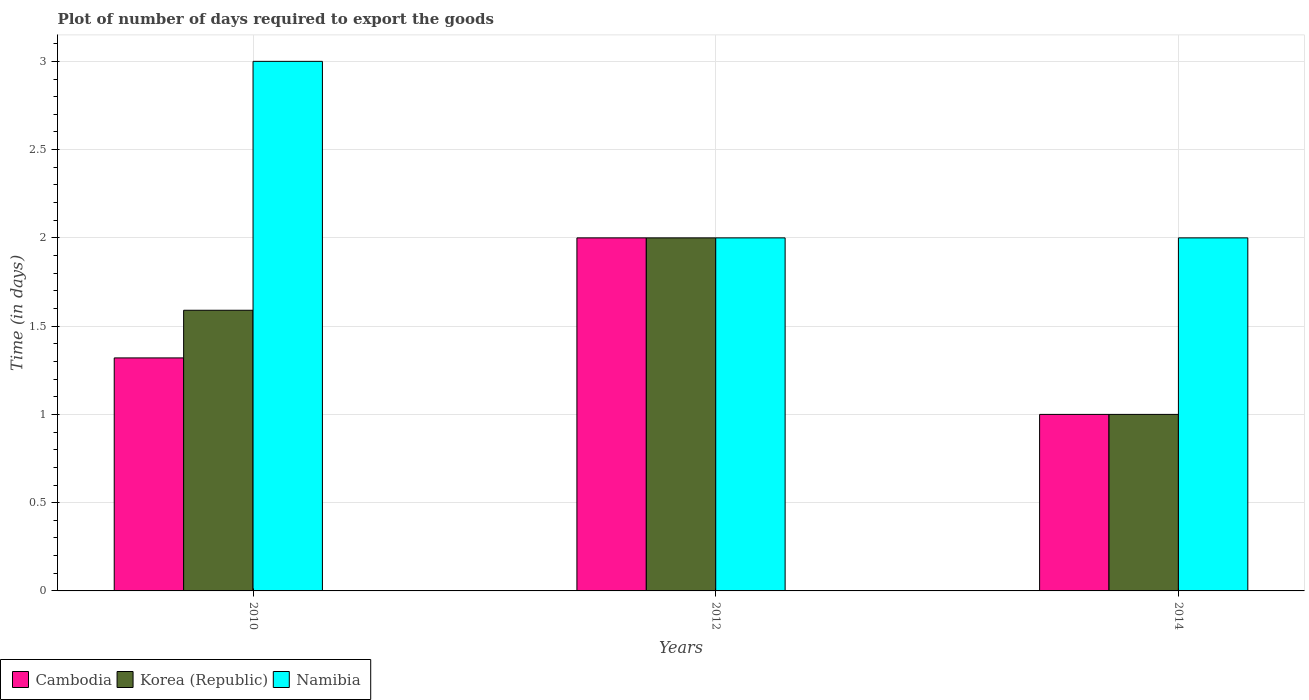Are the number of bars per tick equal to the number of legend labels?
Keep it short and to the point. Yes. How many bars are there on the 2nd tick from the right?
Your response must be concise. 3. What is the time required to export goods in Korea (Republic) in 2010?
Give a very brief answer. 1.59. Across all years, what is the maximum time required to export goods in Cambodia?
Provide a short and direct response. 2. Across all years, what is the minimum time required to export goods in Korea (Republic)?
Provide a succinct answer. 1. What is the total time required to export goods in Cambodia in the graph?
Provide a succinct answer. 4.32. What is the difference between the time required to export goods in Namibia in 2010 and that in 2012?
Offer a very short reply. 1. What is the average time required to export goods in Namibia per year?
Provide a short and direct response. 2.33. What is the ratio of the time required to export goods in Cambodia in 2012 to that in 2014?
Keep it short and to the point. 2. Is the difference between the time required to export goods in Korea (Republic) in 2010 and 2012 greater than the difference between the time required to export goods in Cambodia in 2010 and 2012?
Make the answer very short. Yes. What is the difference between the highest and the second highest time required to export goods in Cambodia?
Keep it short and to the point. 0.68. What is the difference between the highest and the lowest time required to export goods in Namibia?
Provide a succinct answer. 1. Is the sum of the time required to export goods in Namibia in 2010 and 2012 greater than the maximum time required to export goods in Cambodia across all years?
Your response must be concise. Yes. What does the 2nd bar from the left in 2014 represents?
Provide a short and direct response. Korea (Republic). What does the 1st bar from the right in 2014 represents?
Your answer should be very brief. Namibia. Are all the bars in the graph horizontal?
Your answer should be very brief. No. How many years are there in the graph?
Offer a terse response. 3. Does the graph contain any zero values?
Your answer should be very brief. No. Does the graph contain grids?
Make the answer very short. Yes. How are the legend labels stacked?
Provide a short and direct response. Horizontal. What is the title of the graph?
Offer a very short reply. Plot of number of days required to export the goods. Does "Czech Republic" appear as one of the legend labels in the graph?
Provide a succinct answer. No. What is the label or title of the X-axis?
Keep it short and to the point. Years. What is the label or title of the Y-axis?
Provide a short and direct response. Time (in days). What is the Time (in days) of Cambodia in 2010?
Offer a terse response. 1.32. What is the Time (in days) in Korea (Republic) in 2010?
Your answer should be very brief. 1.59. What is the Time (in days) of Namibia in 2012?
Provide a succinct answer. 2. What is the Time (in days) of Cambodia in 2014?
Keep it short and to the point. 1. What is the Time (in days) of Korea (Republic) in 2014?
Your response must be concise. 1. Across all years, what is the minimum Time (in days) in Cambodia?
Provide a succinct answer. 1. What is the total Time (in days) in Cambodia in the graph?
Offer a terse response. 4.32. What is the total Time (in days) of Korea (Republic) in the graph?
Provide a short and direct response. 4.59. What is the total Time (in days) in Namibia in the graph?
Your response must be concise. 7. What is the difference between the Time (in days) in Cambodia in 2010 and that in 2012?
Offer a very short reply. -0.68. What is the difference between the Time (in days) of Korea (Republic) in 2010 and that in 2012?
Offer a terse response. -0.41. What is the difference between the Time (in days) of Namibia in 2010 and that in 2012?
Your answer should be very brief. 1. What is the difference between the Time (in days) in Cambodia in 2010 and that in 2014?
Give a very brief answer. 0.32. What is the difference between the Time (in days) in Korea (Republic) in 2010 and that in 2014?
Provide a succinct answer. 0.59. What is the difference between the Time (in days) in Cambodia in 2010 and the Time (in days) in Korea (Republic) in 2012?
Make the answer very short. -0.68. What is the difference between the Time (in days) in Cambodia in 2010 and the Time (in days) in Namibia in 2012?
Your answer should be compact. -0.68. What is the difference between the Time (in days) of Korea (Republic) in 2010 and the Time (in days) of Namibia in 2012?
Provide a succinct answer. -0.41. What is the difference between the Time (in days) of Cambodia in 2010 and the Time (in days) of Korea (Republic) in 2014?
Provide a short and direct response. 0.32. What is the difference between the Time (in days) of Cambodia in 2010 and the Time (in days) of Namibia in 2014?
Provide a succinct answer. -0.68. What is the difference between the Time (in days) in Korea (Republic) in 2010 and the Time (in days) in Namibia in 2014?
Ensure brevity in your answer.  -0.41. What is the difference between the Time (in days) of Cambodia in 2012 and the Time (in days) of Namibia in 2014?
Your response must be concise. 0. What is the difference between the Time (in days) in Korea (Republic) in 2012 and the Time (in days) in Namibia in 2014?
Offer a terse response. 0. What is the average Time (in days) in Cambodia per year?
Keep it short and to the point. 1.44. What is the average Time (in days) in Korea (Republic) per year?
Offer a terse response. 1.53. What is the average Time (in days) in Namibia per year?
Your answer should be compact. 2.33. In the year 2010, what is the difference between the Time (in days) in Cambodia and Time (in days) in Korea (Republic)?
Your answer should be compact. -0.27. In the year 2010, what is the difference between the Time (in days) of Cambodia and Time (in days) of Namibia?
Your answer should be compact. -1.68. In the year 2010, what is the difference between the Time (in days) of Korea (Republic) and Time (in days) of Namibia?
Your response must be concise. -1.41. In the year 2012, what is the difference between the Time (in days) in Cambodia and Time (in days) in Namibia?
Your answer should be very brief. 0. In the year 2014, what is the difference between the Time (in days) of Cambodia and Time (in days) of Namibia?
Give a very brief answer. -1. What is the ratio of the Time (in days) of Cambodia in 2010 to that in 2012?
Give a very brief answer. 0.66. What is the ratio of the Time (in days) of Korea (Republic) in 2010 to that in 2012?
Offer a very short reply. 0.8. What is the ratio of the Time (in days) of Cambodia in 2010 to that in 2014?
Provide a succinct answer. 1.32. What is the ratio of the Time (in days) in Korea (Republic) in 2010 to that in 2014?
Ensure brevity in your answer.  1.59. What is the ratio of the Time (in days) in Cambodia in 2012 to that in 2014?
Your response must be concise. 2. What is the ratio of the Time (in days) in Korea (Republic) in 2012 to that in 2014?
Offer a very short reply. 2. What is the difference between the highest and the second highest Time (in days) of Cambodia?
Offer a terse response. 0.68. What is the difference between the highest and the second highest Time (in days) of Korea (Republic)?
Keep it short and to the point. 0.41. What is the difference between the highest and the second highest Time (in days) of Namibia?
Give a very brief answer. 1. What is the difference between the highest and the lowest Time (in days) of Cambodia?
Ensure brevity in your answer.  1. What is the difference between the highest and the lowest Time (in days) in Korea (Republic)?
Make the answer very short. 1. What is the difference between the highest and the lowest Time (in days) of Namibia?
Provide a short and direct response. 1. 